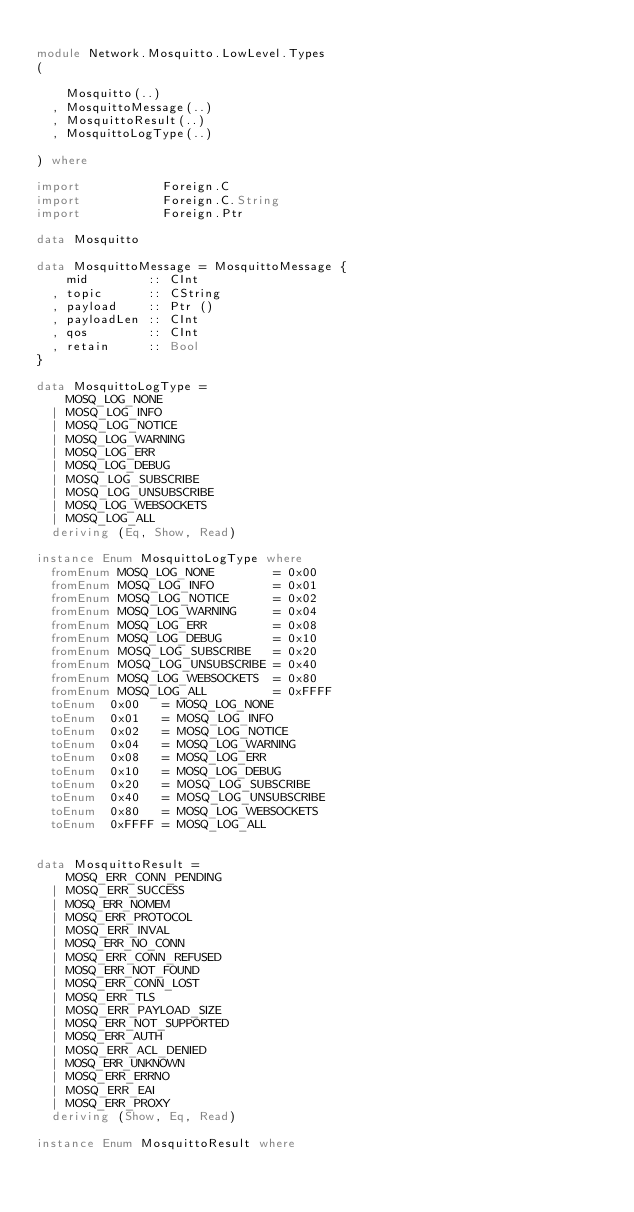<code> <loc_0><loc_0><loc_500><loc_500><_Haskell_>
module Network.Mosquitto.LowLevel.Types
(

    Mosquitto(..)
  , MosquittoMessage(..)
  , MosquittoResult(..)
  , MosquittoLogType(..)

) where

import           Foreign.C
import           Foreign.C.String
import           Foreign.Ptr

data Mosquitto

data MosquittoMessage = MosquittoMessage {
    mid        :: CInt
  , topic      :: CString
  , payload    :: Ptr ()
  , payloadLen :: CInt
  , qos        :: CInt
  , retain     :: Bool
}

data MosquittoLogType =
    MOSQ_LOG_NONE
  | MOSQ_LOG_INFO
  | MOSQ_LOG_NOTICE
  | MOSQ_LOG_WARNING
  | MOSQ_LOG_ERR
  | MOSQ_LOG_DEBUG
  | MOSQ_LOG_SUBSCRIBE
  | MOSQ_LOG_UNSUBSCRIBE
  | MOSQ_LOG_WEBSOCKETS
  | MOSQ_LOG_ALL
  deriving (Eq, Show, Read)

instance Enum MosquittoLogType where
  fromEnum MOSQ_LOG_NONE        = 0x00
  fromEnum MOSQ_LOG_INFO        = 0x01
  fromEnum MOSQ_LOG_NOTICE      = 0x02
  fromEnum MOSQ_LOG_WARNING     = 0x04
  fromEnum MOSQ_LOG_ERR         = 0x08
  fromEnum MOSQ_LOG_DEBUG       = 0x10
  fromEnum MOSQ_LOG_SUBSCRIBE   = 0x20
  fromEnum MOSQ_LOG_UNSUBSCRIBE = 0x40
  fromEnum MOSQ_LOG_WEBSOCKETS  = 0x80
  fromEnum MOSQ_LOG_ALL         = 0xFFFF
  toEnum  0x00   = MOSQ_LOG_NONE
  toEnum  0x01   = MOSQ_LOG_INFO
  toEnum  0x02   = MOSQ_LOG_NOTICE
  toEnum  0x04   = MOSQ_LOG_WARNING
  toEnum  0x08   = MOSQ_LOG_ERR
  toEnum  0x10   = MOSQ_LOG_DEBUG
  toEnum  0x20   = MOSQ_LOG_SUBSCRIBE
  toEnum  0x40   = MOSQ_LOG_UNSUBSCRIBE
  toEnum  0x80   = MOSQ_LOG_WEBSOCKETS
  toEnum  0xFFFF = MOSQ_LOG_ALL


data MosquittoResult =
    MOSQ_ERR_CONN_PENDING
  | MOSQ_ERR_SUCCESS
  | MOSQ_ERR_NOMEM
  | MOSQ_ERR_PROTOCOL
  | MOSQ_ERR_INVAL
  | MOSQ_ERR_NO_CONN
  | MOSQ_ERR_CONN_REFUSED
  | MOSQ_ERR_NOT_FOUND
  | MOSQ_ERR_CONN_LOST
  | MOSQ_ERR_TLS
  | MOSQ_ERR_PAYLOAD_SIZE
  | MOSQ_ERR_NOT_SUPPORTED
  | MOSQ_ERR_AUTH
  | MOSQ_ERR_ACL_DENIED
  | MOSQ_ERR_UNKNOWN
  | MOSQ_ERR_ERRNO
  | MOSQ_ERR_EAI
  | MOSQ_ERR_PROXY
  deriving (Show, Eq, Read)

instance Enum MosquittoResult where</code> 